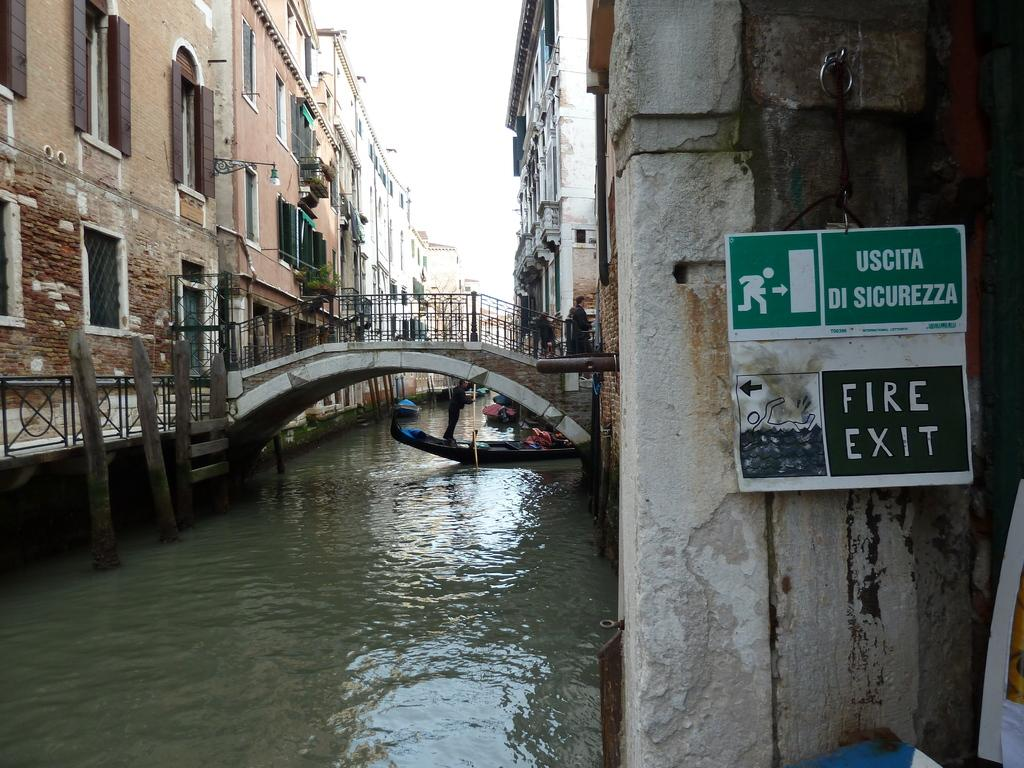What type of structures can be seen in the image? There are buildings in the image. What connects the two sides of the water in the image? There is a bridge in the image. What is present on a wall in the image? There is a sign board on a wall in the image. What is floating on the water in the image? There is a boat on the water in the image. What can be seen in the background of the image? The sky is visible in the background of the image. Where is the bike located in the image? There is no bike present in the image. What type of cheese can be seen on the bridge in the image? There is no cheese present in the image; it features a bridge, buildings, a boat, and a sign board. --- Facts: 1. There is a person holding a book in the image. 2. The person is sitting on a chair. 3. There is a table in the image. 4. The table has a lamp on it. 5. The background of the image is a room. Absurd Topics: elephant, ocean, parachute Conversation: What is the person in the image holding? The person is holding a book in the image. What is the person sitting on in the image? The person is sitting on a chair in the image. What is present in the image besides the person and the book? There is a table in the image, and the table has a lamp on it. What can be seen in the background of the image? The background of the image is a room. Reasoning: Let's think step by step in order to produce the conversation. We start by identifying the main subject in the image, which is the person holding a book. Then, we expand the conversation to include other items that are also visible, such as the chair, table, and lamp. Each question is designed to elicit a specific detail about the image that is known from the provided facts. Absurd Question/Answer: Can you see an elephant swimming in the ocean in the image? There is no elephant or ocean present in the image; it features a person, a book, a chair, a table, a lamp, and a room. Is the person wearing a parachute in the image? There is no parachute present in the image; the person is simply holding a book and sitting on a chair. 